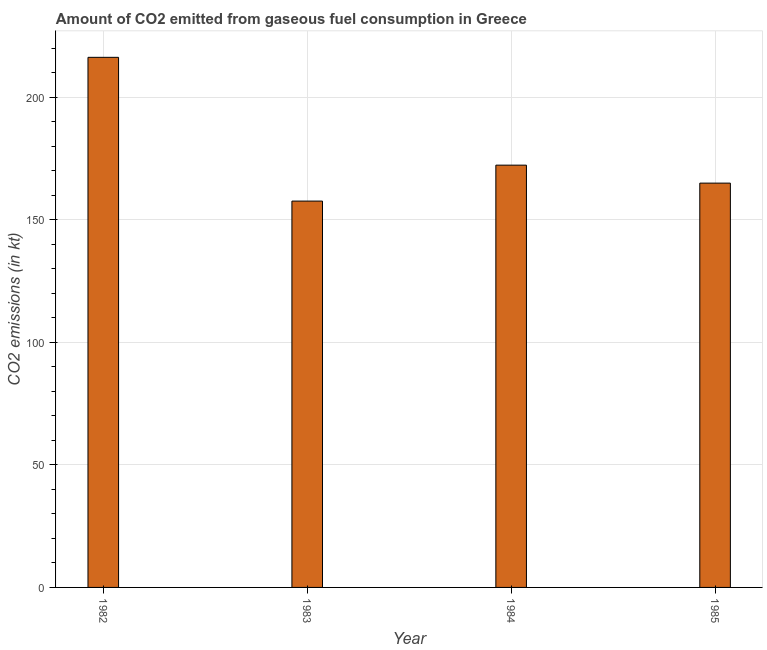What is the title of the graph?
Provide a short and direct response. Amount of CO2 emitted from gaseous fuel consumption in Greece. What is the label or title of the Y-axis?
Offer a terse response. CO2 emissions (in kt). What is the co2 emissions from gaseous fuel consumption in 1985?
Provide a short and direct response. 165.01. Across all years, what is the maximum co2 emissions from gaseous fuel consumption?
Give a very brief answer. 216.35. Across all years, what is the minimum co2 emissions from gaseous fuel consumption?
Your answer should be compact. 157.68. In which year was the co2 emissions from gaseous fuel consumption maximum?
Give a very brief answer. 1982. What is the sum of the co2 emissions from gaseous fuel consumption?
Your response must be concise. 711.4. What is the difference between the co2 emissions from gaseous fuel consumption in 1982 and 1985?
Keep it short and to the point. 51.34. What is the average co2 emissions from gaseous fuel consumption per year?
Keep it short and to the point. 177.85. What is the median co2 emissions from gaseous fuel consumption?
Your response must be concise. 168.68. Do a majority of the years between 1984 and 1983 (inclusive) have co2 emissions from gaseous fuel consumption greater than 110 kt?
Offer a very short reply. No. What is the ratio of the co2 emissions from gaseous fuel consumption in 1983 to that in 1985?
Your answer should be very brief. 0.96. Is the difference between the co2 emissions from gaseous fuel consumption in 1984 and 1985 greater than the difference between any two years?
Provide a succinct answer. No. What is the difference between the highest and the second highest co2 emissions from gaseous fuel consumption?
Your answer should be compact. 44. Is the sum of the co2 emissions from gaseous fuel consumption in 1983 and 1984 greater than the maximum co2 emissions from gaseous fuel consumption across all years?
Offer a terse response. Yes. What is the difference between the highest and the lowest co2 emissions from gaseous fuel consumption?
Your response must be concise. 58.67. In how many years, is the co2 emissions from gaseous fuel consumption greater than the average co2 emissions from gaseous fuel consumption taken over all years?
Keep it short and to the point. 1. How many bars are there?
Give a very brief answer. 4. Are all the bars in the graph horizontal?
Your answer should be very brief. No. What is the CO2 emissions (in kt) of 1982?
Your answer should be compact. 216.35. What is the CO2 emissions (in kt) of 1983?
Make the answer very short. 157.68. What is the CO2 emissions (in kt) in 1984?
Offer a terse response. 172.35. What is the CO2 emissions (in kt) in 1985?
Your answer should be very brief. 165.01. What is the difference between the CO2 emissions (in kt) in 1982 and 1983?
Ensure brevity in your answer.  58.67. What is the difference between the CO2 emissions (in kt) in 1982 and 1984?
Ensure brevity in your answer.  44. What is the difference between the CO2 emissions (in kt) in 1982 and 1985?
Ensure brevity in your answer.  51.34. What is the difference between the CO2 emissions (in kt) in 1983 and 1984?
Provide a short and direct response. -14.67. What is the difference between the CO2 emissions (in kt) in 1983 and 1985?
Ensure brevity in your answer.  -7.33. What is the difference between the CO2 emissions (in kt) in 1984 and 1985?
Keep it short and to the point. 7.33. What is the ratio of the CO2 emissions (in kt) in 1982 to that in 1983?
Your answer should be compact. 1.37. What is the ratio of the CO2 emissions (in kt) in 1982 to that in 1984?
Offer a very short reply. 1.25. What is the ratio of the CO2 emissions (in kt) in 1982 to that in 1985?
Your answer should be compact. 1.31. What is the ratio of the CO2 emissions (in kt) in 1983 to that in 1984?
Your response must be concise. 0.92. What is the ratio of the CO2 emissions (in kt) in 1983 to that in 1985?
Ensure brevity in your answer.  0.96. What is the ratio of the CO2 emissions (in kt) in 1984 to that in 1985?
Make the answer very short. 1.04. 